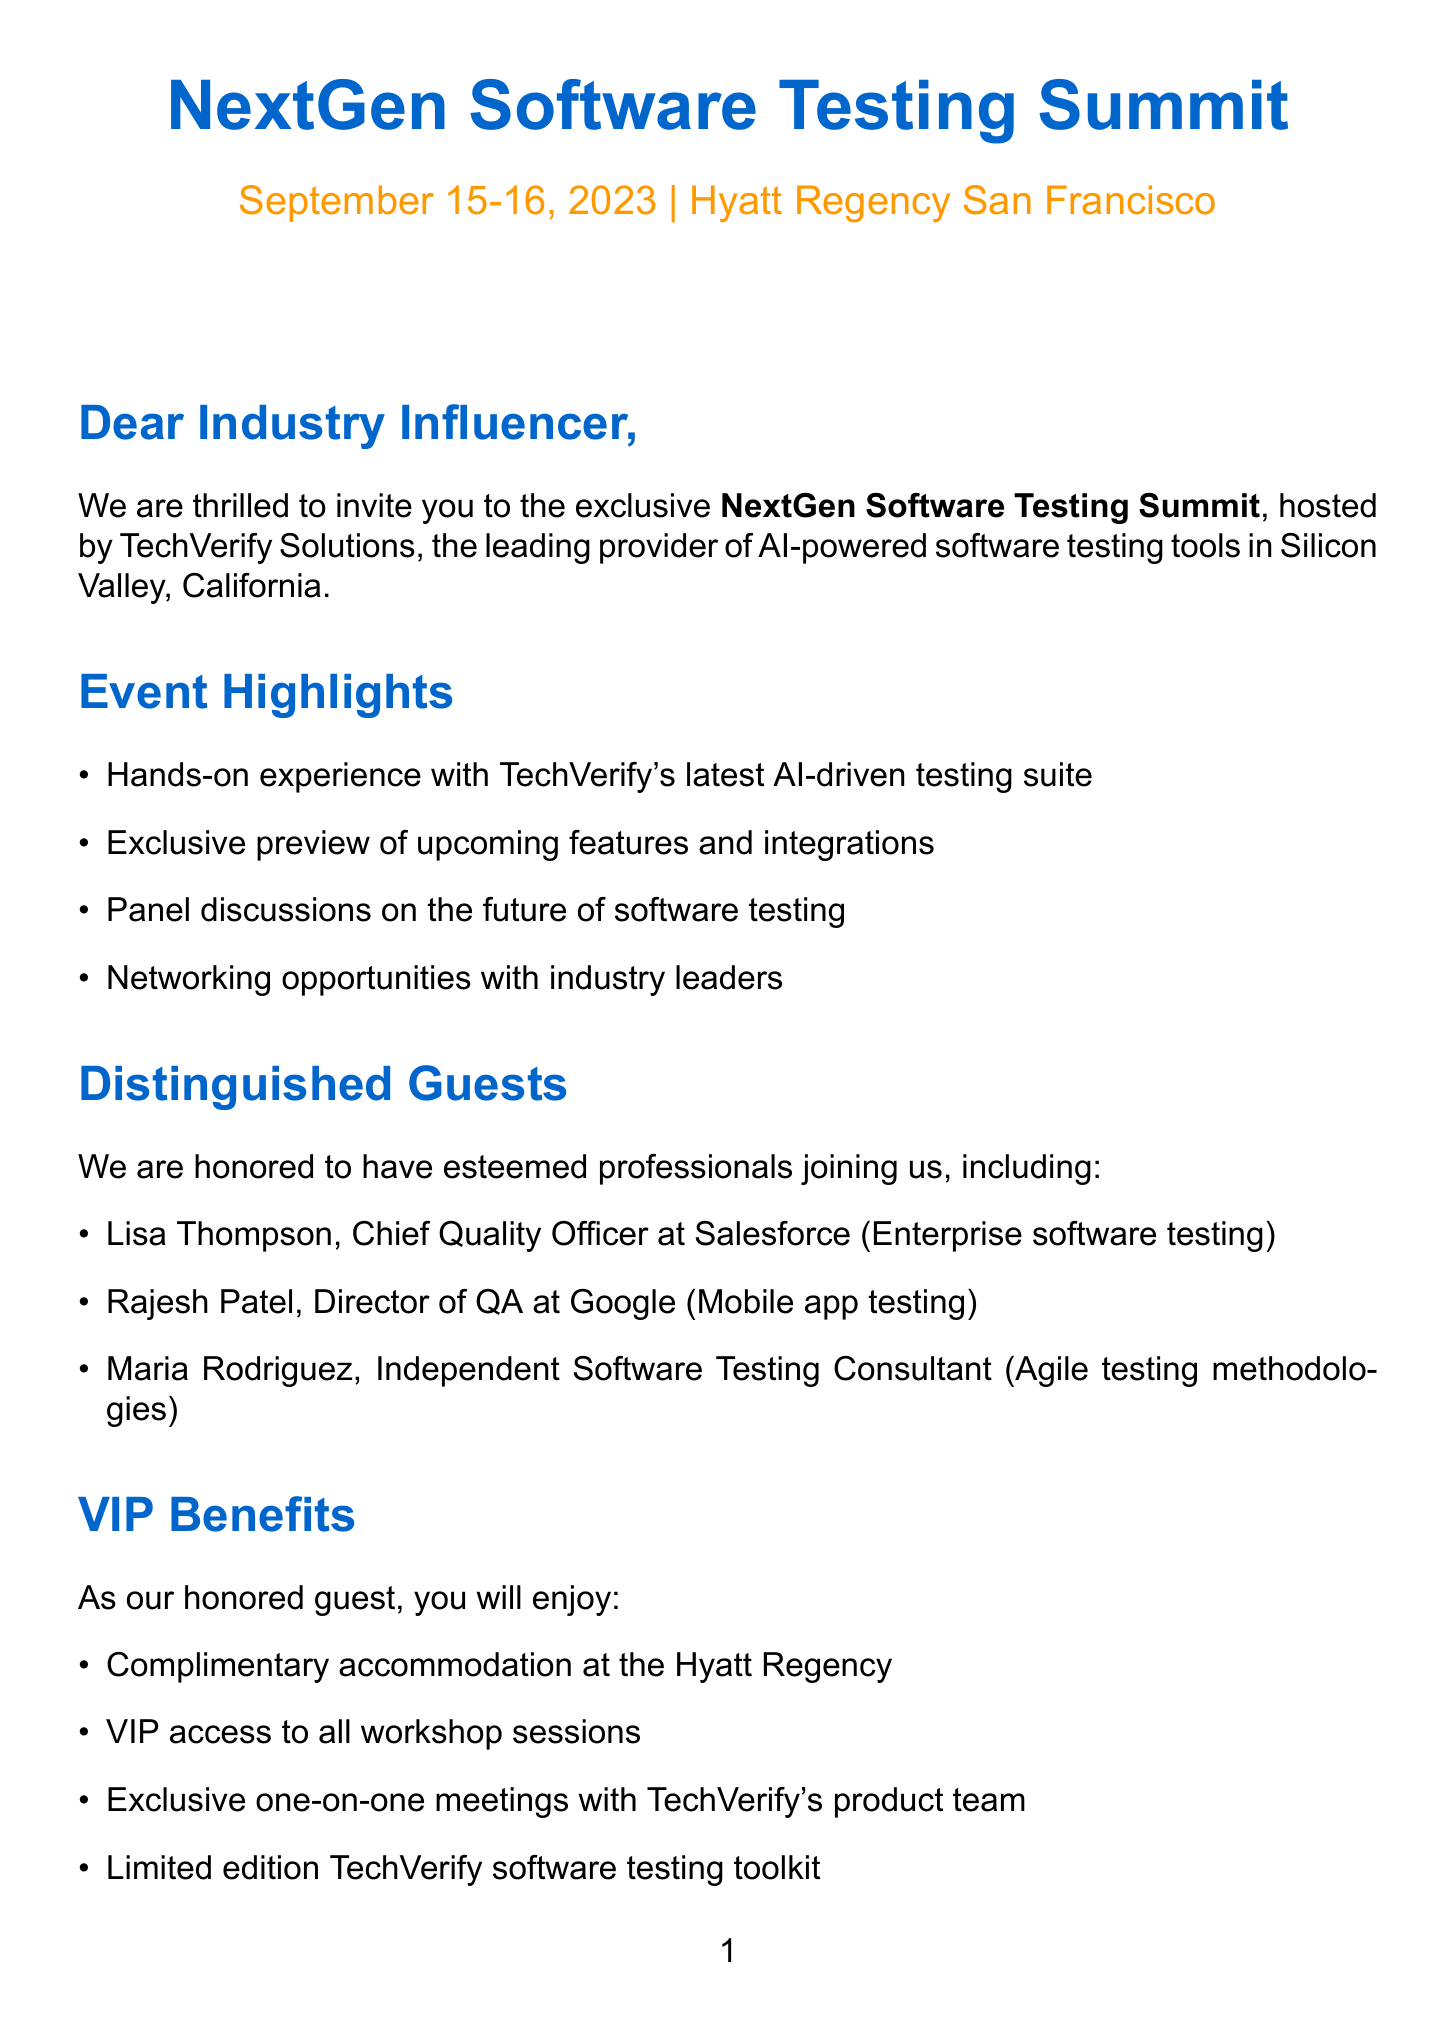What is the name of the event? The name of the event is explicitly stated in the document as the "NextGen Software Testing Summit."
Answer: NextGen Software Testing Summit When is the summit taking place? The document provides the specific dates for the summit, which are September 15-16, 2023.
Answer: September 15-16, 2023 Who is the Chief Quality Officer at Salesforce? The document lists Lisa Thompson as the Chief Quality Officer at Salesforce.
Answer: Lisa Thompson What is one of the VIP benefits offered to guests? The document lists several VIP benefits, one being "Complimentary accommodation at the Hyatt Regency."
Answer: Complimentary accommodation at the Hyatt Regency Which social media platforms should attendees use to share their experience? The document specifies that attendees should share their experiences on LinkedIn, Twitter, Instagram, and YouTube.
Answer: LinkedIn, Twitter, Instagram, YouTube How long is the workshop? The event duration is specified in the document as "2 days."
Answer: 2 days What is a potential outcome of providing a review? According to the document, one outcome is receiving "early access to beta versions of upcoming products."
Answer: Early access to beta versions of upcoming products What hashtag is suggested for sharing experiences? The document suggests using the hashtag "#NextGenTesting."
Answer: #NextGenTesting What does the letter request from industry influencers? The letter requests influencers to share their experience online and provide reviews.
Answer: Share their experience online and provide reviews 